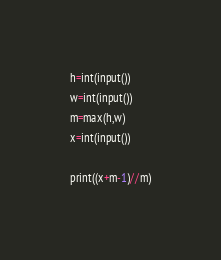<code> <loc_0><loc_0><loc_500><loc_500><_Python_>h=int(input())
w=int(input())
m=max(h,w)
x=int(input())

print((x+m-1)//m)</code> 